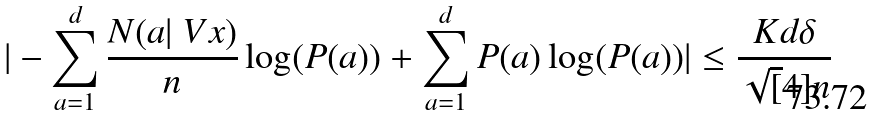<formula> <loc_0><loc_0><loc_500><loc_500>| - \sum _ { a = 1 } ^ { d } \frac { N ( a | \ V x ) } { n } \log ( P ( a ) ) + \sum _ { a = 1 } ^ { d } P ( a ) \log ( P ( a ) ) | \leq \frac { K d \delta } { \sqrt { [ } 4 ] { n } }</formula> 